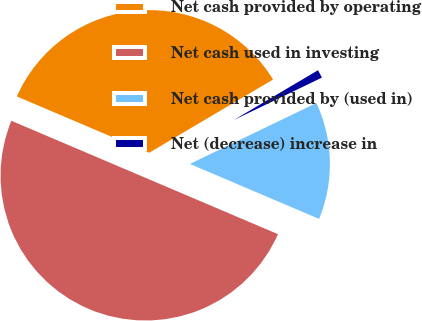Convert chart to OTSL. <chart><loc_0><loc_0><loc_500><loc_500><pie_chart><fcel>Net cash provided by operating<fcel>Net cash used in investing<fcel>Net cash provided by (used in)<fcel>Net (decrease) increase in<nl><fcel>35.1%<fcel>50.0%<fcel>13.54%<fcel>1.36%<nl></chart> 